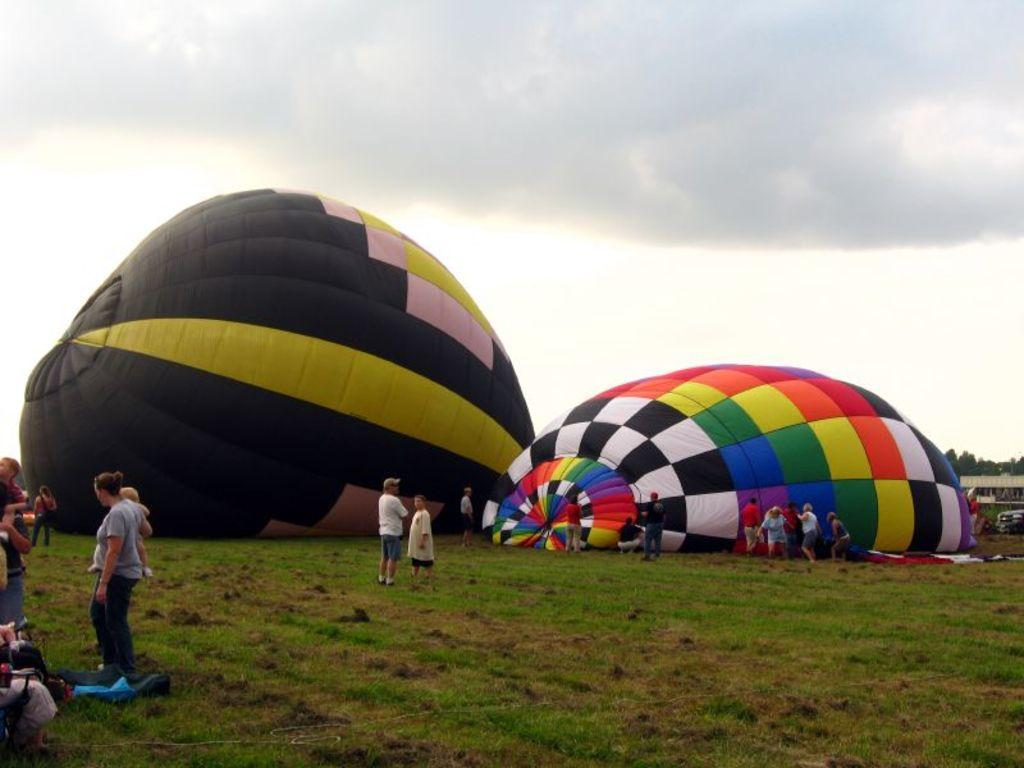What are the two main objects on the ground in the image? There are two hot air balloons on the ground in the image. What else can be seen on the land in the image? There are people standing on the land in the image. What is visible in the background of the image? There are trees and the sky visible in the background of the image. What type of chin can be seen on the hot air balloons in the image? There are no chins present on the hot air balloons in the image, as they are inanimate objects. 